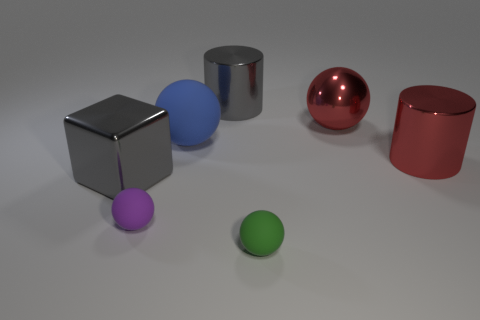What number of spheres are either big purple things or large gray things?
Your answer should be compact. 0. What is the shape of the matte object that is both behind the green thing and in front of the large metal cube?
Offer a very short reply. Sphere. Is the number of metal objects that are behind the large metal ball the same as the number of large blocks that are in front of the tiny purple object?
Your response must be concise. No. What number of objects are either tiny purple matte things or small green matte blocks?
Offer a very short reply. 1. What is the color of the other thing that is the same size as the purple thing?
Keep it short and to the point. Green. What number of things are either matte balls behind the gray block or large metallic things on the right side of the large blue sphere?
Provide a short and direct response. 4. Are there an equal number of big gray metal cylinders that are in front of the big red sphere and gray shiny spheres?
Offer a very short reply. Yes. Is the size of the rubber thing that is behind the large metallic cube the same as the rubber thing that is right of the big blue rubber ball?
Offer a very short reply. No. What number of other things are the same size as the metal cube?
Ensure brevity in your answer.  4. There is a red object that is to the left of the big cylinder to the right of the green thing; are there any small matte objects on the left side of it?
Give a very brief answer. Yes. 